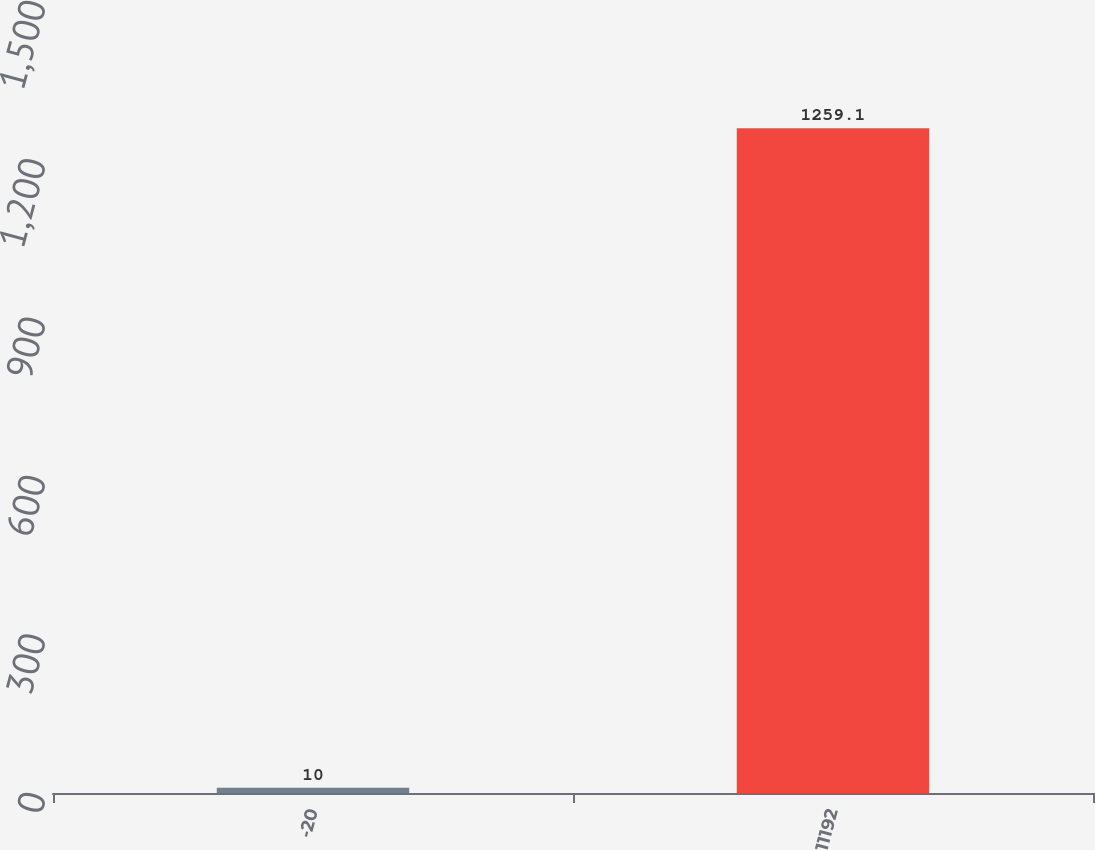Convert chart to OTSL. <chart><loc_0><loc_0><loc_500><loc_500><bar_chart><fcel>-20<fcel>11192<nl><fcel>10<fcel>1259.1<nl></chart> 